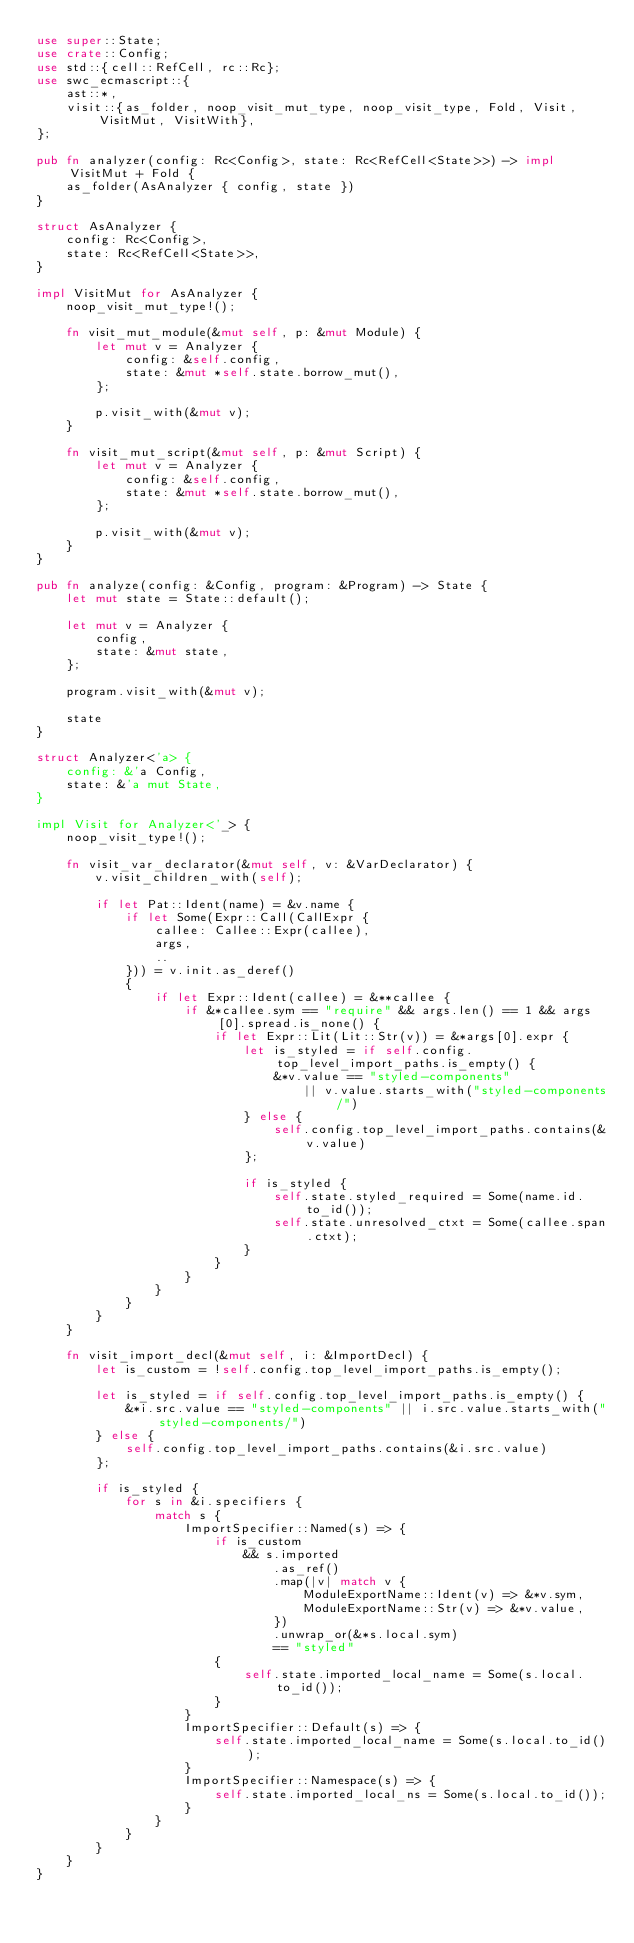<code> <loc_0><loc_0><loc_500><loc_500><_Rust_>use super::State;
use crate::Config;
use std::{cell::RefCell, rc::Rc};
use swc_ecmascript::{
    ast::*,
    visit::{as_folder, noop_visit_mut_type, noop_visit_type, Fold, Visit, VisitMut, VisitWith},
};

pub fn analyzer(config: Rc<Config>, state: Rc<RefCell<State>>) -> impl VisitMut + Fold {
    as_folder(AsAnalyzer { config, state })
}

struct AsAnalyzer {
    config: Rc<Config>,
    state: Rc<RefCell<State>>,
}

impl VisitMut for AsAnalyzer {
    noop_visit_mut_type!();

    fn visit_mut_module(&mut self, p: &mut Module) {
        let mut v = Analyzer {
            config: &self.config,
            state: &mut *self.state.borrow_mut(),
        };

        p.visit_with(&mut v);
    }

    fn visit_mut_script(&mut self, p: &mut Script) {
        let mut v = Analyzer {
            config: &self.config,
            state: &mut *self.state.borrow_mut(),
        };

        p.visit_with(&mut v);
    }
}

pub fn analyze(config: &Config, program: &Program) -> State {
    let mut state = State::default();

    let mut v = Analyzer {
        config,
        state: &mut state,
    };

    program.visit_with(&mut v);

    state
}

struct Analyzer<'a> {
    config: &'a Config,
    state: &'a mut State,
}

impl Visit for Analyzer<'_> {
    noop_visit_type!();

    fn visit_var_declarator(&mut self, v: &VarDeclarator) {
        v.visit_children_with(self);

        if let Pat::Ident(name) = &v.name {
            if let Some(Expr::Call(CallExpr {
                callee: Callee::Expr(callee),
                args,
                ..
            })) = v.init.as_deref()
            {
                if let Expr::Ident(callee) = &**callee {
                    if &*callee.sym == "require" && args.len() == 1 && args[0].spread.is_none() {
                        if let Expr::Lit(Lit::Str(v)) = &*args[0].expr {
                            let is_styled = if self.config.top_level_import_paths.is_empty() {
                                &*v.value == "styled-components"
                                    || v.value.starts_with("styled-components/")
                            } else {
                                self.config.top_level_import_paths.contains(&v.value)
                            };

                            if is_styled {
                                self.state.styled_required = Some(name.id.to_id());
                                self.state.unresolved_ctxt = Some(callee.span.ctxt);
                            }
                        }
                    }
                }
            }
        }
    }

    fn visit_import_decl(&mut self, i: &ImportDecl) {
        let is_custom = !self.config.top_level_import_paths.is_empty();

        let is_styled = if self.config.top_level_import_paths.is_empty() {
            &*i.src.value == "styled-components" || i.src.value.starts_with("styled-components/")
        } else {
            self.config.top_level_import_paths.contains(&i.src.value)
        };

        if is_styled {
            for s in &i.specifiers {
                match s {
                    ImportSpecifier::Named(s) => {
                        if is_custom
                            && s.imported
                                .as_ref()
                                .map(|v| match v {
                                    ModuleExportName::Ident(v) => &*v.sym,
                                    ModuleExportName::Str(v) => &*v.value,
                                })
                                .unwrap_or(&*s.local.sym)
                                == "styled"
                        {
                            self.state.imported_local_name = Some(s.local.to_id());
                        }
                    }
                    ImportSpecifier::Default(s) => {
                        self.state.imported_local_name = Some(s.local.to_id());
                    }
                    ImportSpecifier::Namespace(s) => {
                        self.state.imported_local_ns = Some(s.local.to_id());
                    }
                }
            }
        }
    }
}
</code> 